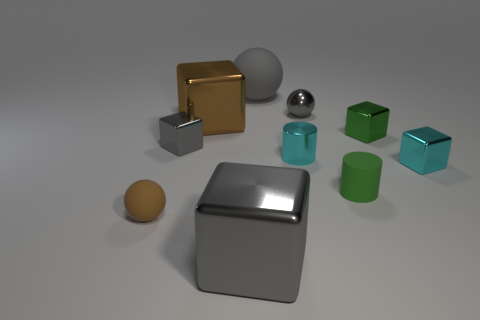What is the size of the cyan metal thing that is on the left side of the cyan block?
Make the answer very short. Small. Do the matte ball behind the brown sphere and the gray shiny cube in front of the small brown object have the same size?
Your response must be concise. Yes. What number of brown objects are the same material as the cyan cylinder?
Offer a very short reply. 1. The large matte ball has what color?
Your answer should be compact. Gray. Are there any balls in front of the small green metallic object?
Offer a terse response. Yes. Is the big matte ball the same color as the rubber cylinder?
Your answer should be very brief. No. How many tiny shiny things have the same color as the large matte sphere?
Make the answer very short. 2. What size is the cylinder that is in front of the small metal object on the right side of the tiny green metallic object?
Your answer should be compact. Small. The large brown shiny object is what shape?
Ensure brevity in your answer.  Cube. There is a large gray thing that is behind the small cyan metal cylinder; what material is it?
Your answer should be compact. Rubber. 